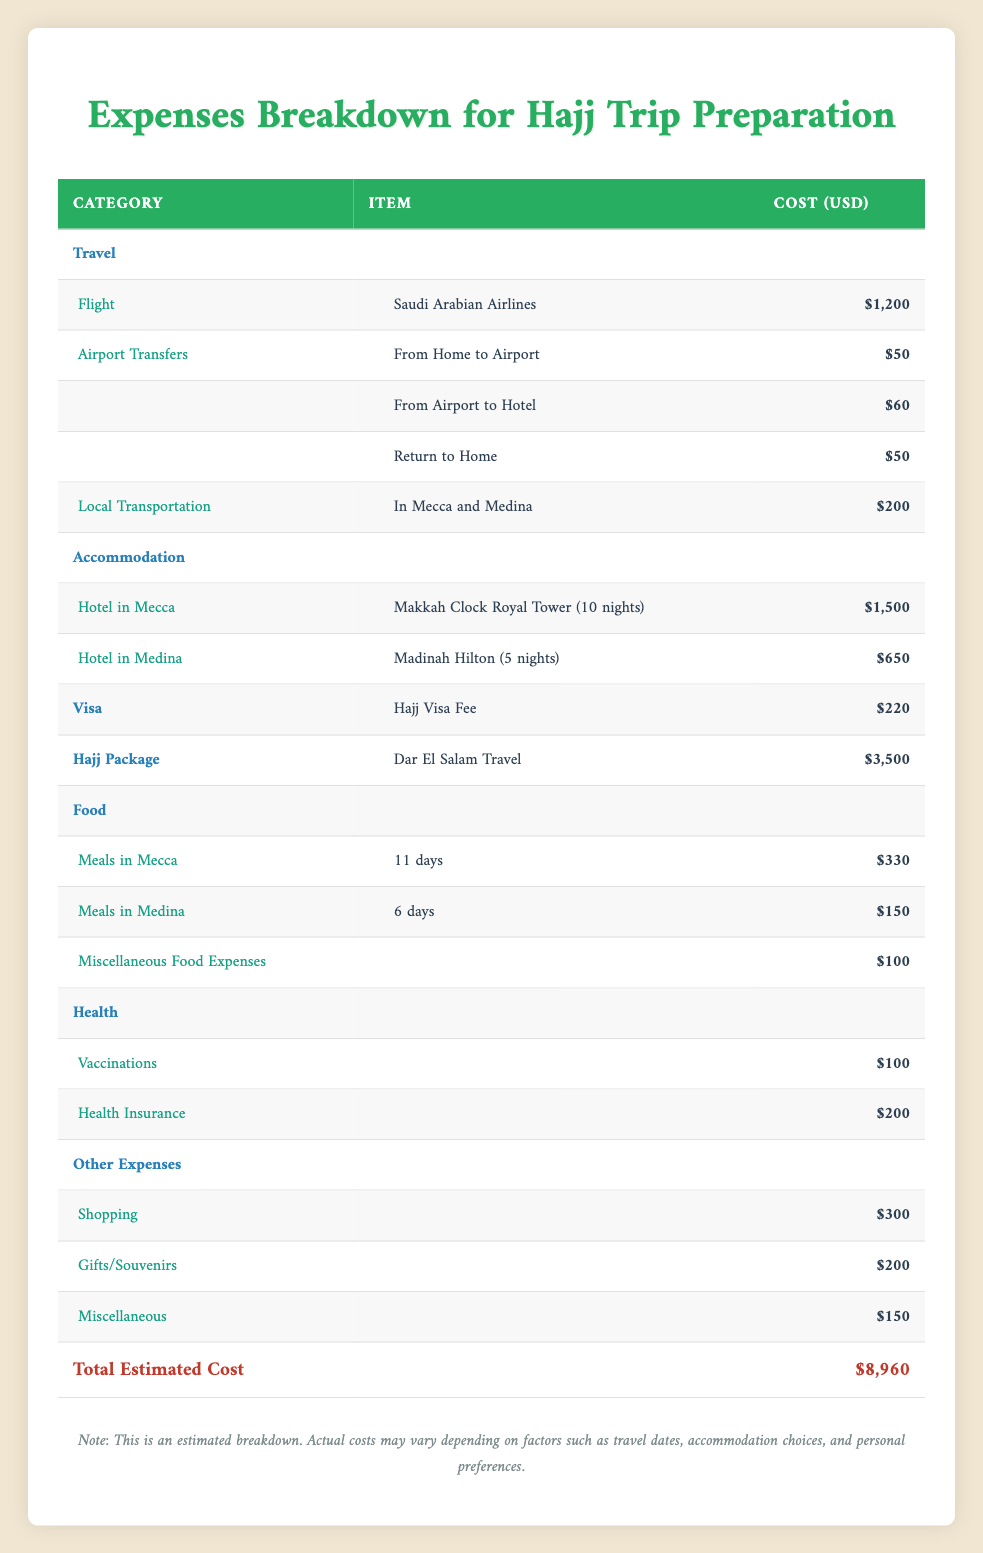What is the total estimated cost for the Hajj trip preparation? The total estimated cost is found in the last row of the table under "Total Estimated Cost," which shows a value of $7445.
Answer: $7445 What is the cost of the flight with Saudi Arabian Airlines? The cost of the flight is listed under the "Flight" category in the "Travel" section. It shows a cost of $1200.
Answer: $1200 How much will the meals in Mecca cost for 11 days? Meals in Mecca are charged at $30 per day for 11 days. Therefore, to calculate the total: 30 x 11 = $330.
Answer: $330 Are the vaccinations covered under health expenses? Yes, vaccinations are listed as a health expense with a cost of $100.
Answer: Yes What is the total cost for accommodation in Mecca for 10 nights? The hotel in Mecca is the Makkah Clock Royal Tower, which costs $150 per night for 10 nights. To find the total: 150 x 10 = $1500.
Answer: $1500 What is the combined total cost for shopping and miscellaneous expenses? The table shows $300 for shopping and $150 for miscellaneous expenses. The combined total is 300 + 150 = $450.
Answer: $450 How much more does the Hajj package cost compared to the Hajj visa fee? The Hajj package costs $3500, while the Hajj visa fee is $220. To find the difference: 3500 - 220 = $3280.
Answer: $3280 Is the cost for local transportation in Mecca and Medina less than $250? The cost for local transportation is listed as $200, which is indeed less than $250.
Answer: Yes How much are food expenses in Medina compared to those in Mecca? The total food expenses in Medina are $150 (for 6 days) and in Mecca are $330 (for 11 days). Thus, 330 - 150 = $180, indicating meals in Mecca cost more.
Answer: Meals in Mecca cost $180 more 